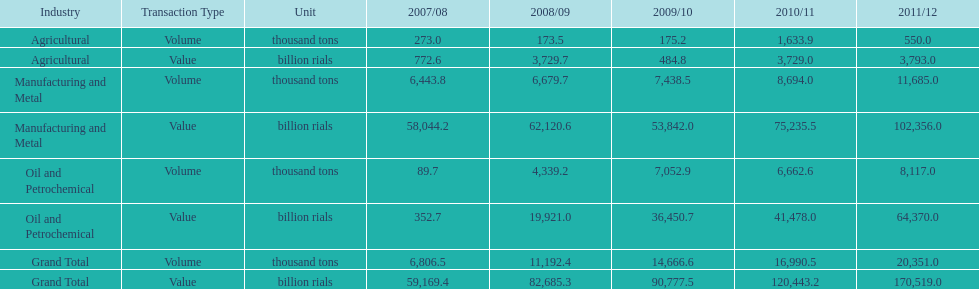Which year had the largest agricultural volume? 2010/11. 